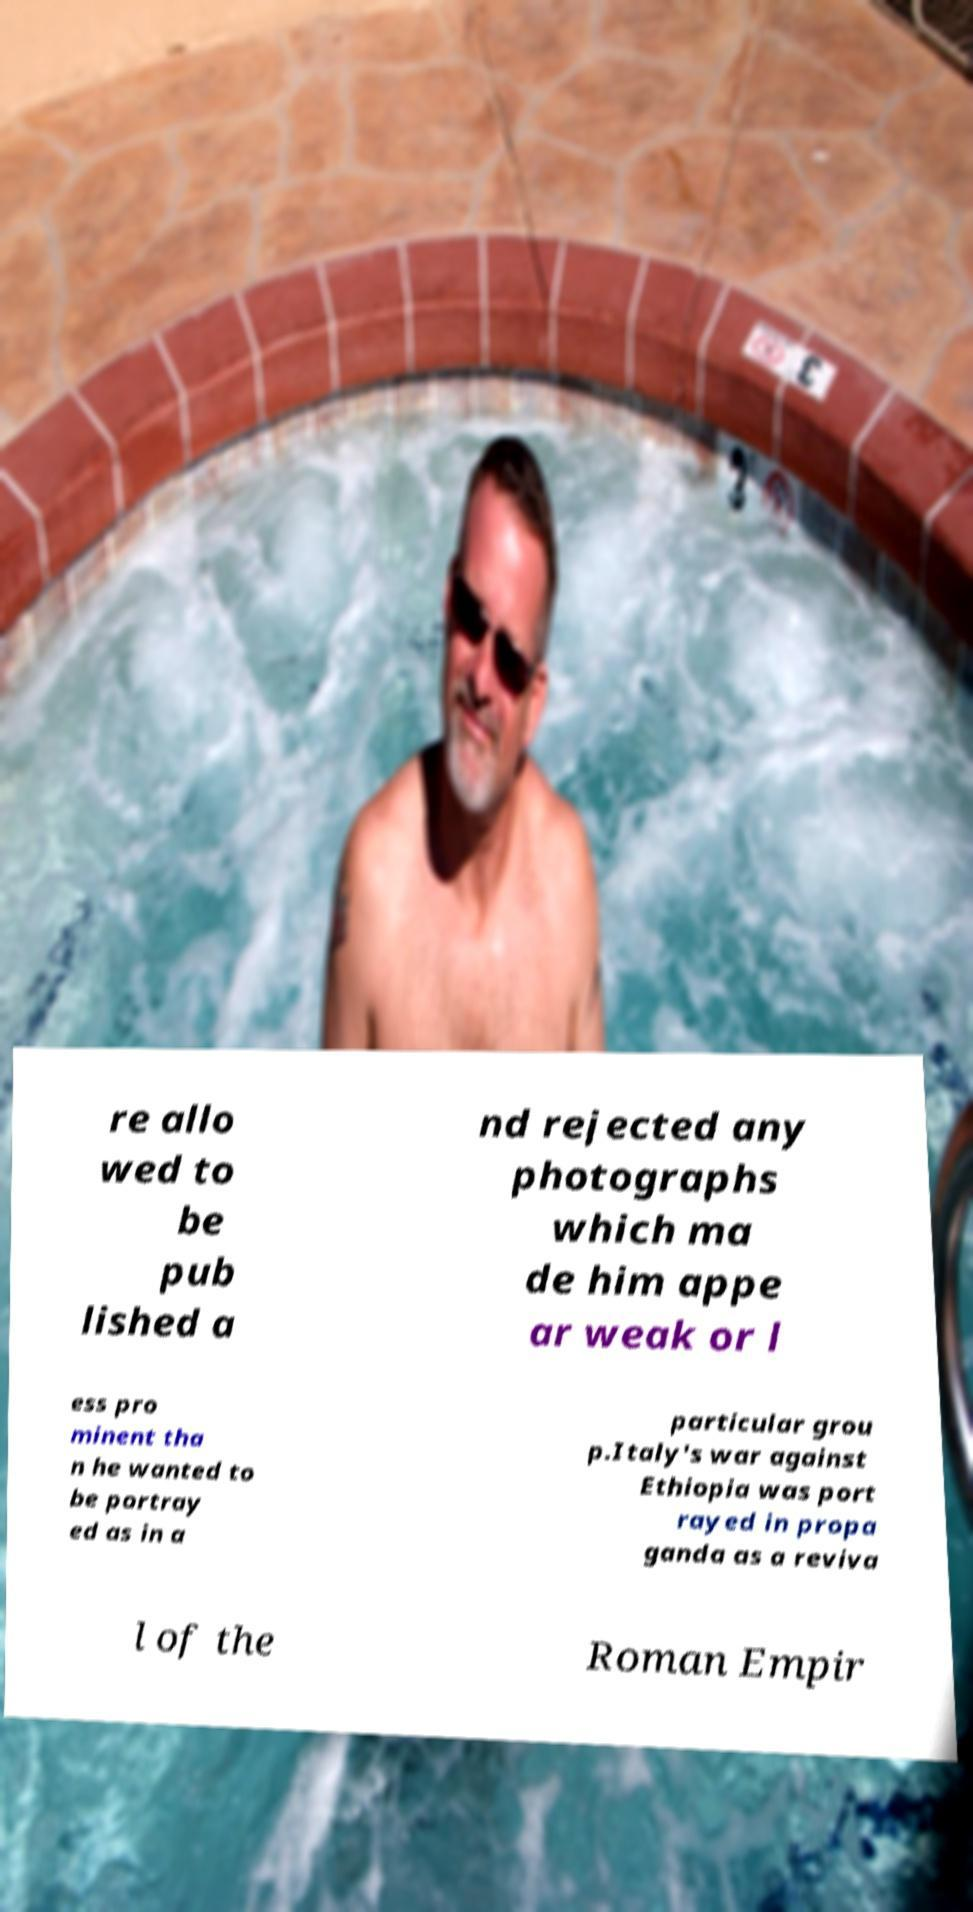Can you accurately transcribe the text from the provided image for me? re allo wed to be pub lished a nd rejected any photographs which ma de him appe ar weak or l ess pro minent tha n he wanted to be portray ed as in a particular grou p.Italy's war against Ethiopia was port rayed in propa ganda as a reviva l of the Roman Empir 